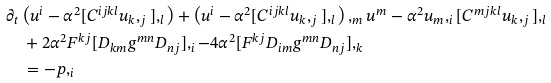Convert formula to latex. <formula><loc_0><loc_0><loc_500><loc_500>& \partial _ { t } \left ( u ^ { i } - \alpha ^ { 2 } [ C ^ { i j k l } u _ { k } , _ { j } ] , _ { l } \right ) + \left ( u ^ { i } - \alpha ^ { 2 } [ C ^ { i j k l } u _ { k } , _ { j } ] , _ { l } \right ) , _ { m } u ^ { m } - \alpha ^ { 2 } u _ { m } , _ { i } [ C ^ { m j k l } u _ { k } , _ { j } ] , _ { l } \\ & \quad + 2 \alpha ^ { 2 } F ^ { k j } [ D _ { k m } g ^ { m n } D _ { n j } ] , _ { i } - 4 \alpha ^ { 2 } [ F ^ { k j } D _ { i m } g ^ { m n } D _ { n j } ] , _ { k } \\ & \quad = - p , _ { i }</formula> 